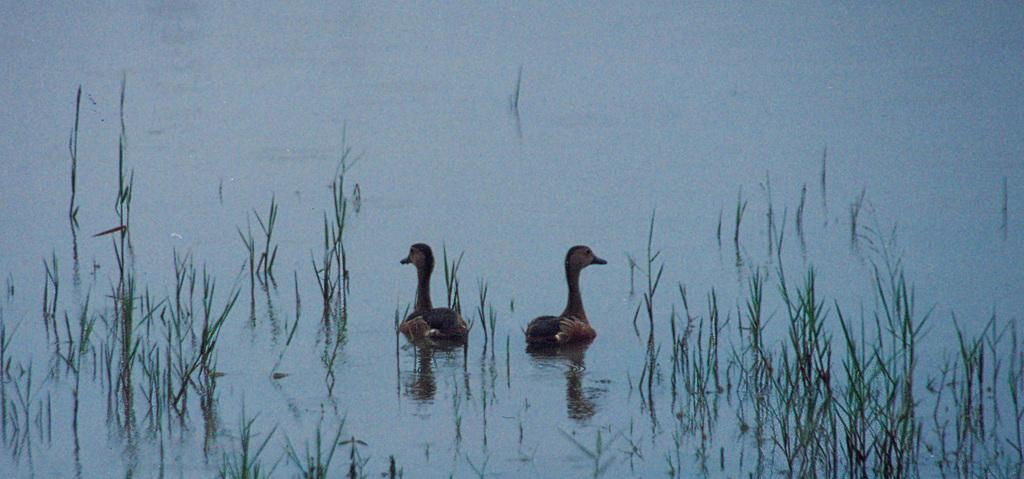What animals can be seen in the image? There are two small ducks in the image. Where are the ducks located? The ducks are in the lake water. What type of vegetation is visible in the image? There is green grass visible in the image. What type of approval is the duck receiving from the oranges in the image? There are no oranges present in the image, and therefore no approval can be given by them. 